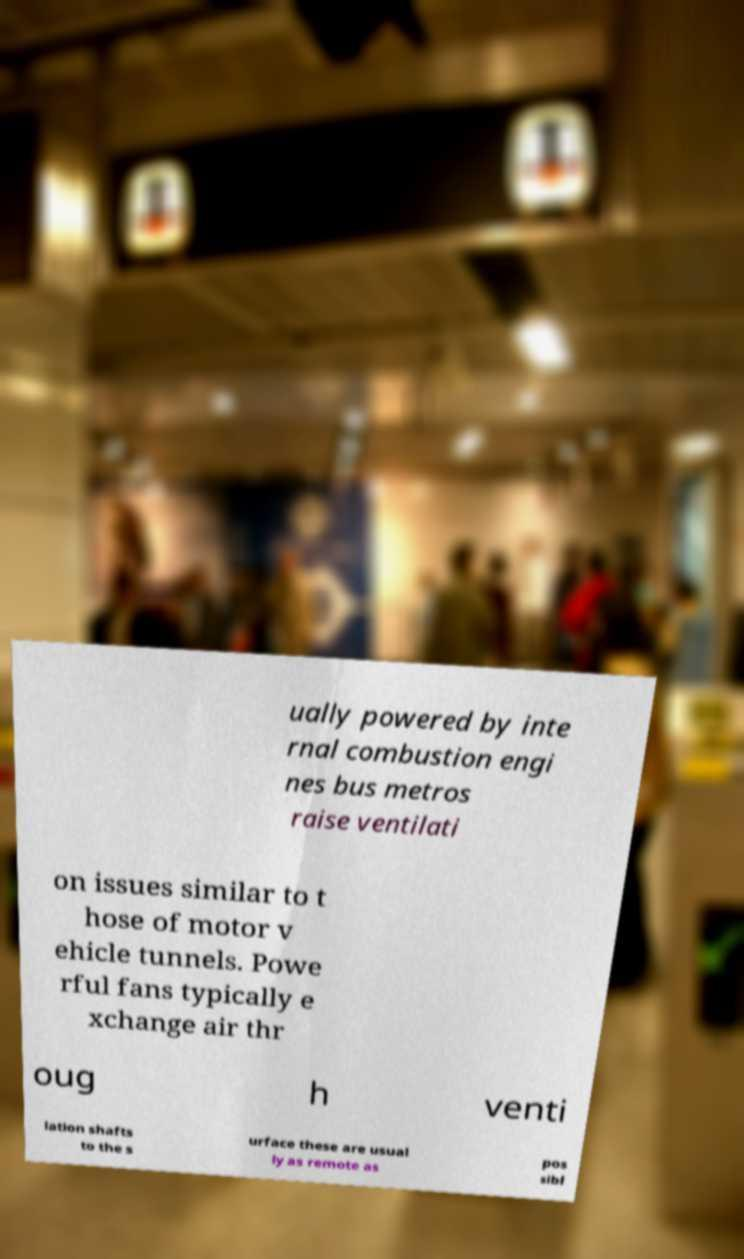Please read and relay the text visible in this image. What does it say? ually powered by inte rnal combustion engi nes bus metros raise ventilati on issues similar to t hose of motor v ehicle tunnels. Powe rful fans typically e xchange air thr oug h venti lation shafts to the s urface these are usual ly as remote as pos sibl 